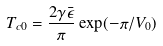<formula> <loc_0><loc_0><loc_500><loc_500>T _ { c 0 } = \frac { 2 \gamma \bar { \epsilon } } { \pi } \exp ( - \pi / V _ { 0 } )</formula> 